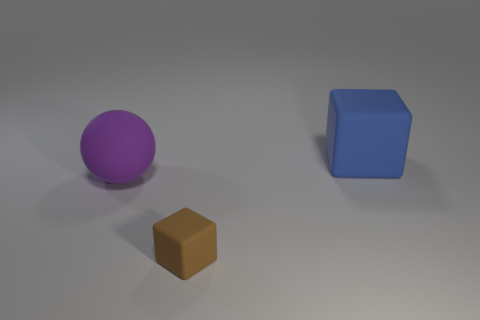Subtract all blue cubes. How many cubes are left? 1 Subtract all cubes. How many objects are left? 1 Add 3 tiny blue cylinders. How many objects exist? 6 Add 1 brown rubber objects. How many brown rubber objects are left? 2 Add 1 big cyan shiny cylinders. How many big cyan shiny cylinders exist? 1 Subtract 0 cyan cubes. How many objects are left? 3 Subtract 1 spheres. How many spheres are left? 0 Subtract all green balls. Subtract all green cubes. How many balls are left? 1 Subtract all brown balls. How many gray cubes are left? 0 Subtract all large green shiny balls. Subtract all blocks. How many objects are left? 1 